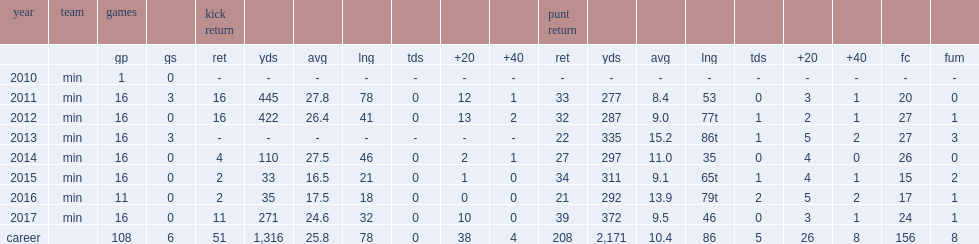How many kick returns did marcus sherels get in 2012? 16.0. 